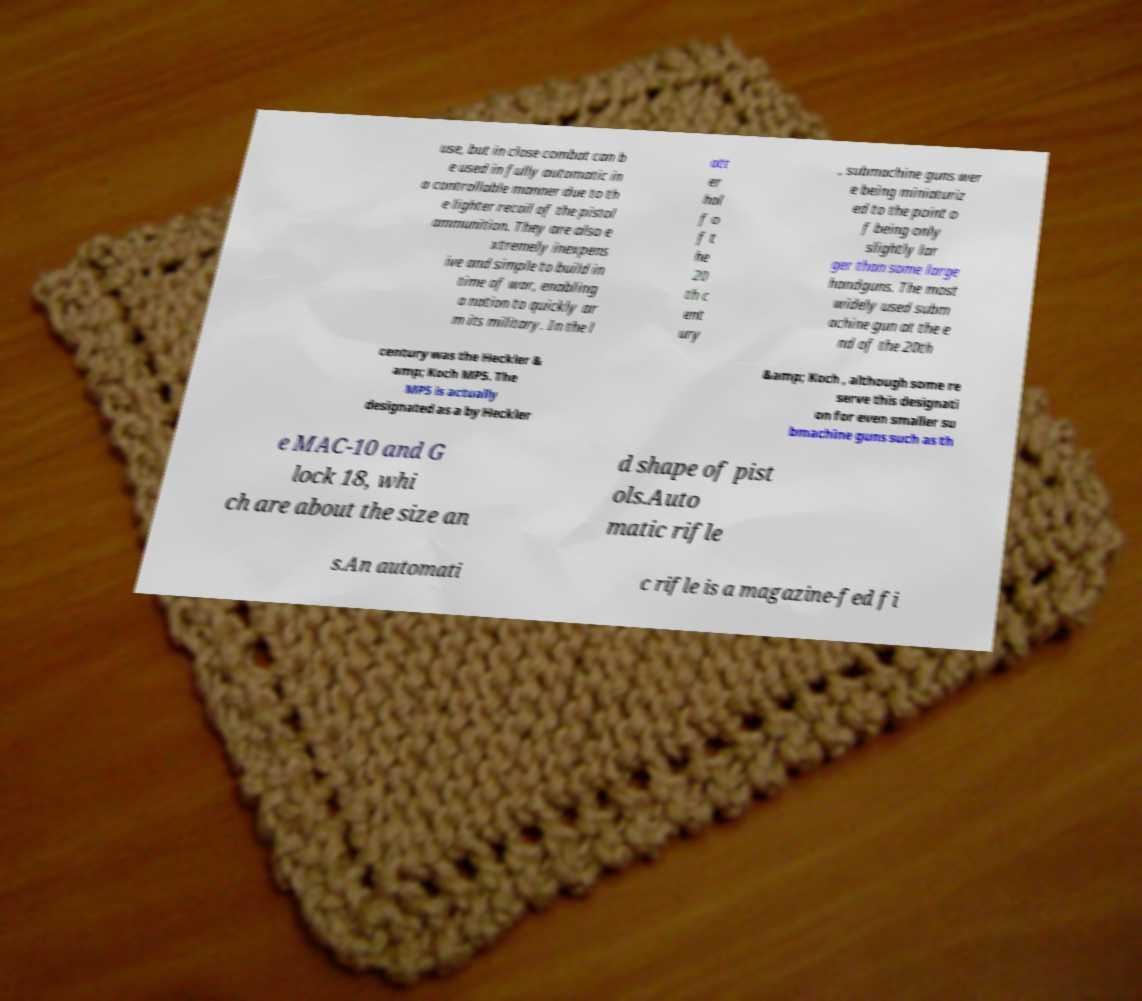For documentation purposes, I need the text within this image transcribed. Could you provide that? use, but in close combat can b e used in fully automatic in a controllable manner due to th e lighter recoil of the pistol ammunition. They are also e xtremely inexpens ive and simple to build in time of war, enabling a nation to quickly ar m its military. In the l att er hal f o f t he 20 th c ent ury , submachine guns wer e being miniaturiz ed to the point o f being only slightly lar ger than some large handguns. The most widely used subm achine gun at the e nd of the 20th century was the Heckler & amp; Koch MP5. The MP5 is actually designated as a by Heckler &amp; Koch , although some re serve this designati on for even smaller su bmachine guns such as th e MAC-10 and G lock 18, whi ch are about the size an d shape of pist ols.Auto matic rifle s.An automati c rifle is a magazine-fed fi 